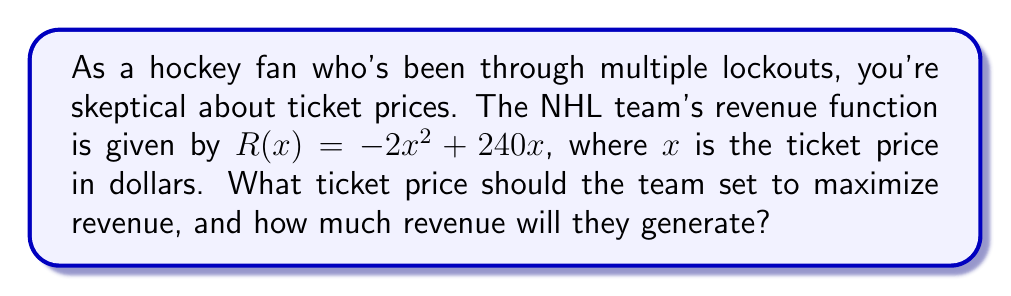Give your solution to this math problem. Let's approach this step-by-step:

1) The revenue function is a quadratic function: $R(x) = -2x^2 + 240x$

2) To find the maximum revenue, we need to find the vertex of this parabola. The x-coordinate of the vertex will give us the optimal ticket price.

3) For a quadratic function in the form $f(x) = ax^2 + bx + c$, the x-coordinate of the vertex is given by $x = -\frac{b}{2a}$

4) In our case, $a = -2$ and $b = 240$. So:

   $x = -\frac{240}{2(-2)} = -\frac{240}{-4} = 60$

5) Therefore, the optimal ticket price is $60.

6) To find the maximum revenue, we substitute $x = 60$ into the original function:

   $R(60) = -2(60)^2 + 240(60)$
   $= -2(3600) + 14400$
   $= -7200 + 14400$
   $= 7200$

7) The maximum revenue is $7200.
Answer: $60 per ticket; $7200 maximum revenue 